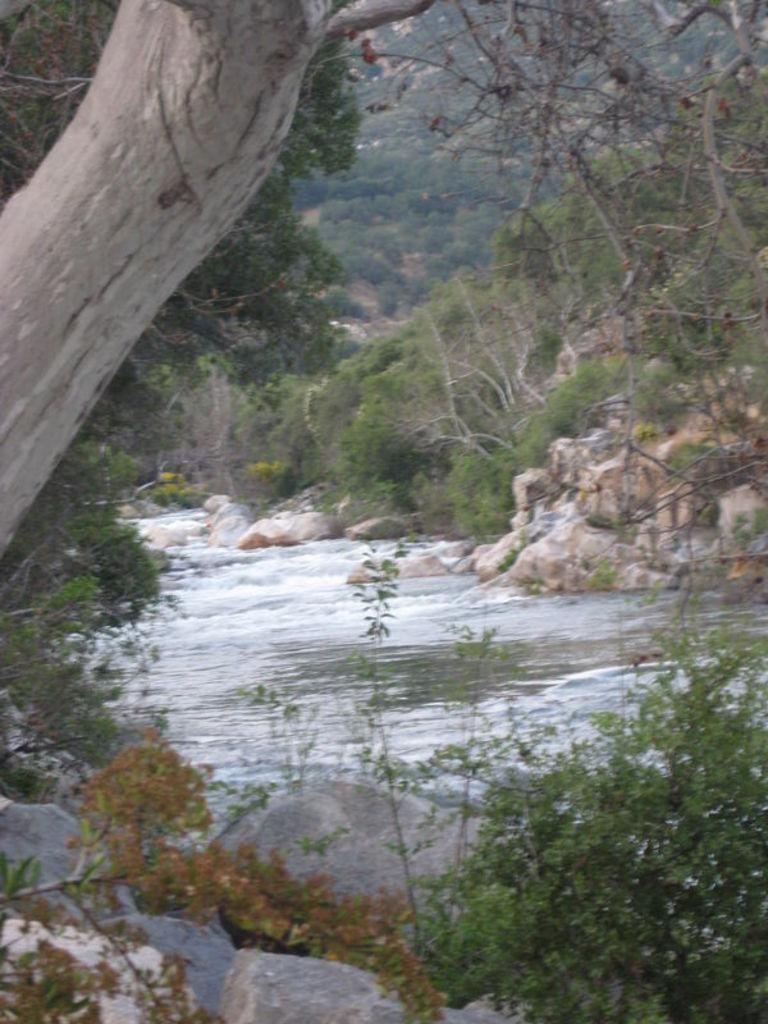Please provide a concise description of this image. In this image there is the water flowing in the center. On the either sides of the water there are rocks and plants. In the background there are trees on the mountain. At the top left there is a tree trunk. 